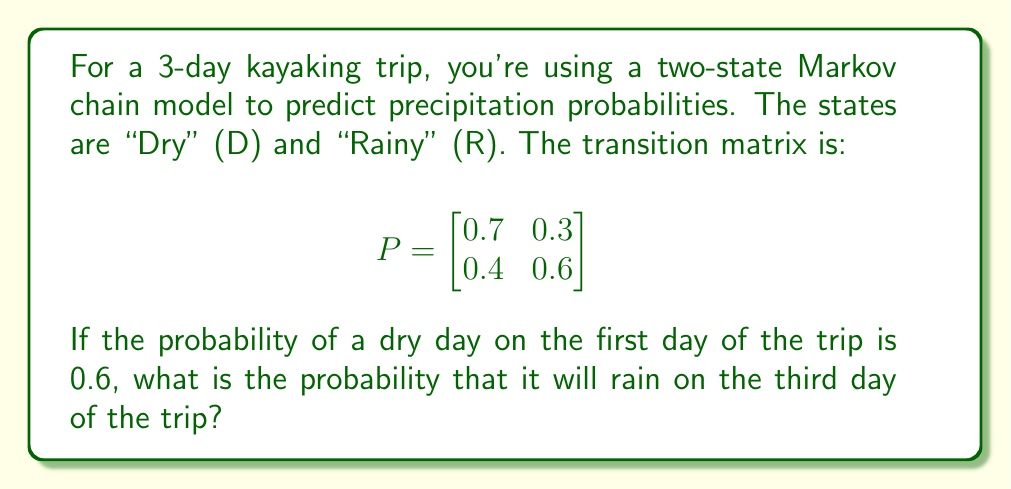Give your solution to this math problem. Let's approach this step-by-step:

1) First, we need to calculate the probability distribution for the second day. We can do this by multiplying the initial probability vector by the transition matrix:

   $$\begin{bmatrix}0.6 & 0.4\end{bmatrix} \cdot \begin{bmatrix}
   0.7 & 0.3 \\
   0.4 & 0.6
   \end{bmatrix} = \begin{bmatrix}0.58 & 0.42\end{bmatrix}$$

2) Now, we need to calculate the probability distribution for the third day. We do this by multiplying the second day's probability vector by the transition matrix again:

   $$\begin{bmatrix}0.58 & 0.42\end{bmatrix} \cdot \begin{bmatrix}
   0.7 & 0.3 \\
   0.4 & 0.6
   \end{bmatrix} = \begin{bmatrix}0.574 & 0.426\end{bmatrix}$$

3) The probability of rain on the third day is the second element of this resulting vector, which represents the probability of being in the "Rainy" state.

Therefore, the probability of rain on the third day of the trip is 0.426 or 42.6%.
Answer: 0.426 